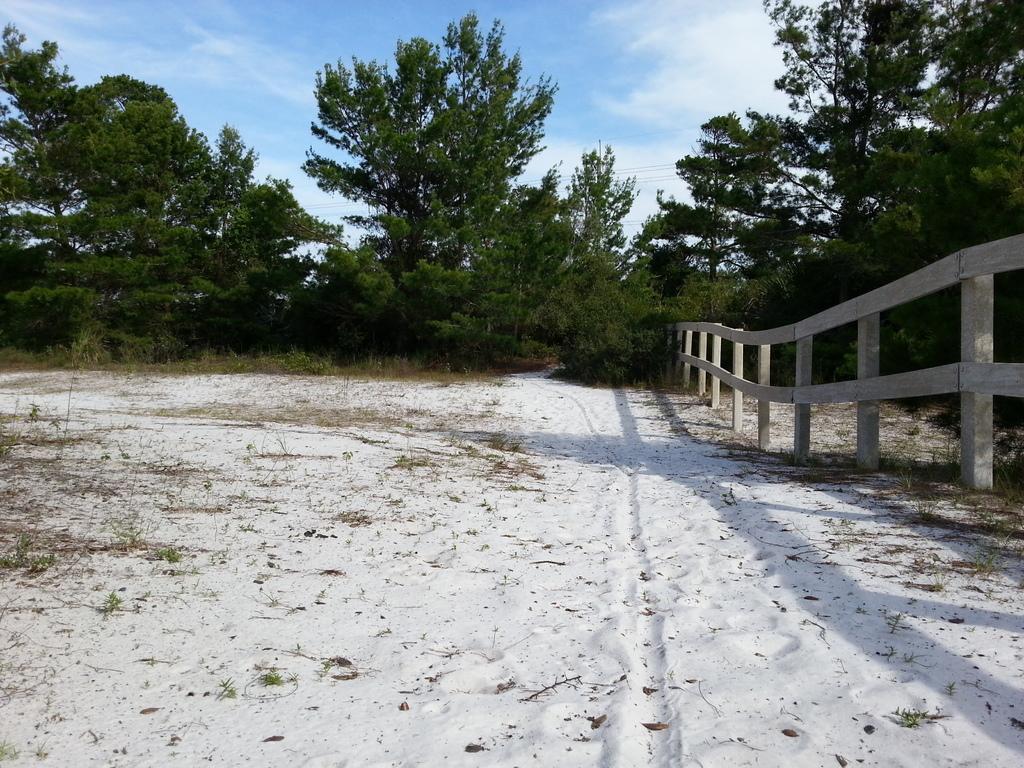How would you summarize this image in a sentence or two? In this image we can see a wooden fence in the sand and in the background there are few trees and the sky with clouds. 